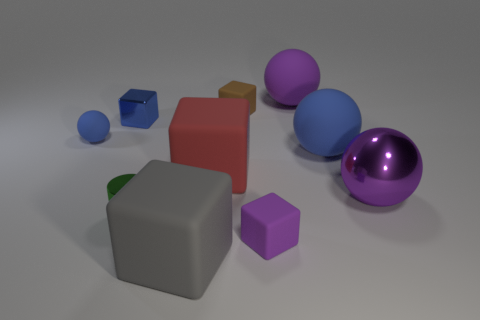Subtract all red blocks. How many blocks are left? 4 Subtract 1 blocks. How many blocks are left? 4 Subtract all small blue metal cubes. How many cubes are left? 4 Subtract all green blocks. Subtract all purple balls. How many blocks are left? 5 Subtract all balls. How many objects are left? 6 Subtract all yellow metal cylinders. Subtract all big spheres. How many objects are left? 7 Add 8 purple matte cubes. How many purple matte cubes are left? 9 Add 7 tiny gray cylinders. How many tiny gray cylinders exist? 7 Subtract 0 yellow balls. How many objects are left? 10 